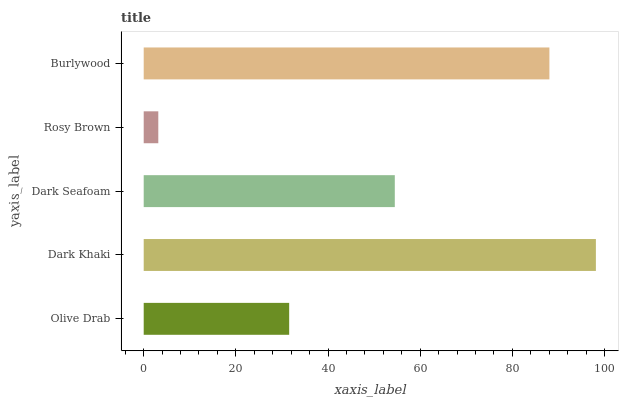Is Rosy Brown the minimum?
Answer yes or no. Yes. Is Dark Khaki the maximum?
Answer yes or no. Yes. Is Dark Seafoam the minimum?
Answer yes or no. No. Is Dark Seafoam the maximum?
Answer yes or no. No. Is Dark Khaki greater than Dark Seafoam?
Answer yes or no. Yes. Is Dark Seafoam less than Dark Khaki?
Answer yes or no. Yes. Is Dark Seafoam greater than Dark Khaki?
Answer yes or no. No. Is Dark Khaki less than Dark Seafoam?
Answer yes or no. No. Is Dark Seafoam the high median?
Answer yes or no. Yes. Is Dark Seafoam the low median?
Answer yes or no. Yes. Is Olive Drab the high median?
Answer yes or no. No. Is Dark Khaki the low median?
Answer yes or no. No. 